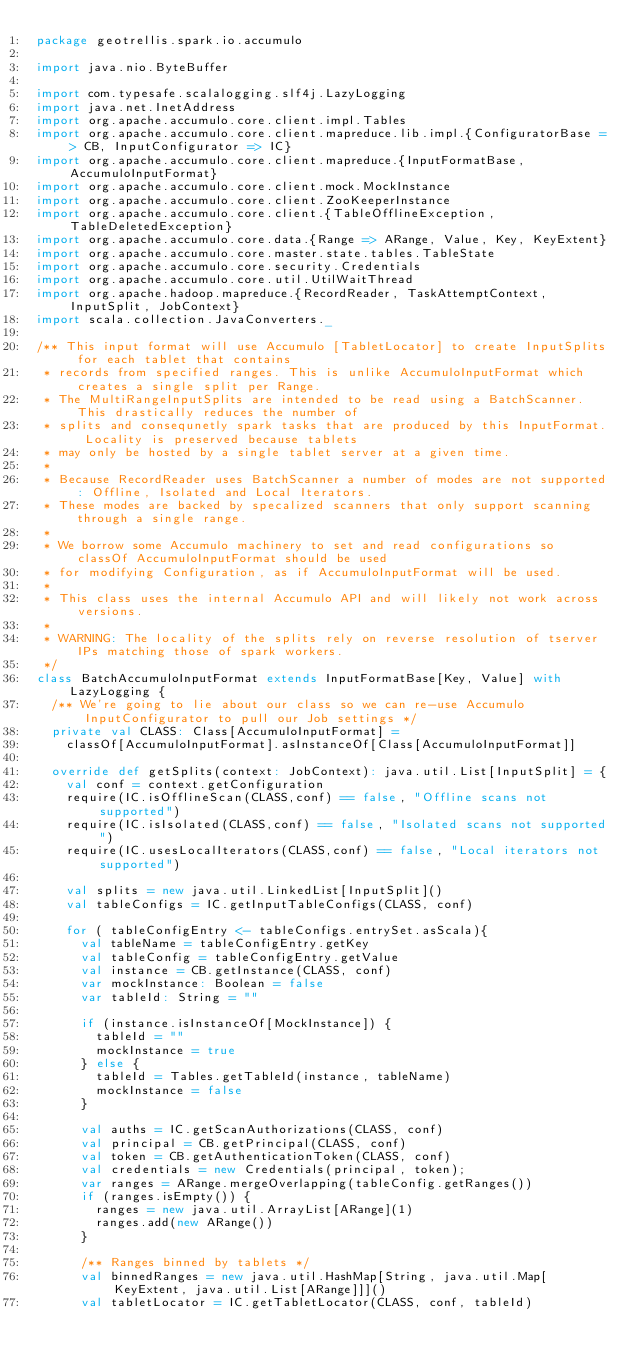<code> <loc_0><loc_0><loc_500><loc_500><_Scala_>package geotrellis.spark.io.accumulo

import java.nio.ByteBuffer

import com.typesafe.scalalogging.slf4j.LazyLogging
import java.net.InetAddress
import org.apache.accumulo.core.client.impl.Tables
import org.apache.accumulo.core.client.mapreduce.lib.impl.{ConfiguratorBase => CB, InputConfigurator => IC}
import org.apache.accumulo.core.client.mapreduce.{InputFormatBase, AccumuloInputFormat}
import org.apache.accumulo.core.client.mock.MockInstance
import org.apache.accumulo.core.client.ZooKeeperInstance
import org.apache.accumulo.core.client.{TableOfflineException, TableDeletedException}
import org.apache.accumulo.core.data.{Range => ARange, Value, Key, KeyExtent}
import org.apache.accumulo.core.master.state.tables.TableState
import org.apache.accumulo.core.security.Credentials
import org.apache.accumulo.core.util.UtilWaitThread
import org.apache.hadoop.mapreduce.{RecordReader, TaskAttemptContext, InputSplit, JobContext}
import scala.collection.JavaConverters._

/** This input format will use Accumulo [TabletLocator] to create InputSplits for each tablet that contains
 * records from specified ranges. This is unlike AccumuloInputFormat which creates a single split per Range.
 * The MultiRangeInputSplits are intended to be read using a BatchScanner. This drastically reduces the number of 
 * splits and consequnetly spark tasks that are produced by this InputFormat. Locality is preserved because tablets
 * may only be hosted by a single tablet server at a given time.
 *
 * Because RecordReader uses BatchScanner a number of modes are not supported: Offline, Isolated and Local Iterators.
 * These modes are backed by specalized scanners that only support scanning through a single range.
 *
 * We borrow some Accumulo machinery to set and read configurations so classOf AccumuloInputFormat should be used 
 * for modifying Configuration, as if AccumuloInputFormat will be used.
 *
 * This class uses the internal Accumulo API and will likely not work across versions.
 *
 * WARNING: The locality of the splits rely on reverse resolution of tserver IPs matching those of spark workers.
 */
class BatchAccumuloInputFormat extends InputFormatBase[Key, Value] with LazyLogging {
  /** We're going to lie about our class so we can re-use Accumulo InputConfigurator to pull our Job settings */
  private val CLASS: Class[AccumuloInputFormat] =
    classOf[AccumuloInputFormat].asInstanceOf[Class[AccumuloInputFormat]]

  override def getSplits(context: JobContext): java.util.List[InputSplit] = {
    val conf = context.getConfiguration
    require(IC.isOfflineScan(CLASS,conf) == false, "Offline scans not supported")
    require(IC.isIsolated(CLASS,conf) == false, "Isolated scans not supported")
    require(IC.usesLocalIterators(CLASS,conf) == false, "Local iterators not supported")

    val splits = new java.util.LinkedList[InputSplit]()
    val tableConfigs = IC.getInputTableConfigs(CLASS, conf)

    for ( tableConfigEntry <- tableConfigs.entrySet.asScala){
      val tableName = tableConfigEntry.getKey
      val tableConfig = tableConfigEntry.getValue
      val instance = CB.getInstance(CLASS, conf)
      var mockInstance: Boolean = false
      var tableId: String = ""

      if (instance.isInstanceOf[MockInstance]) {
        tableId = ""
        mockInstance = true
      } else {
        tableId = Tables.getTableId(instance, tableName)
        mockInstance = false
      }

      val auths = IC.getScanAuthorizations(CLASS, conf)
      val principal = CB.getPrincipal(CLASS, conf)
      val token = CB.getAuthenticationToken(CLASS, conf)
      val credentials = new Credentials(principal, token);
      var ranges = ARange.mergeOverlapping(tableConfig.getRanges())
      if (ranges.isEmpty()) {
        ranges = new java.util.ArrayList[ARange](1)
        ranges.add(new ARange())
      }

      /** Ranges binned by tablets */
      val binnedRanges = new java.util.HashMap[String, java.util.Map[KeyExtent, java.util.List[ARange]]]()
      val tabletLocator = IC.getTabletLocator(CLASS, conf, tableId)</code> 